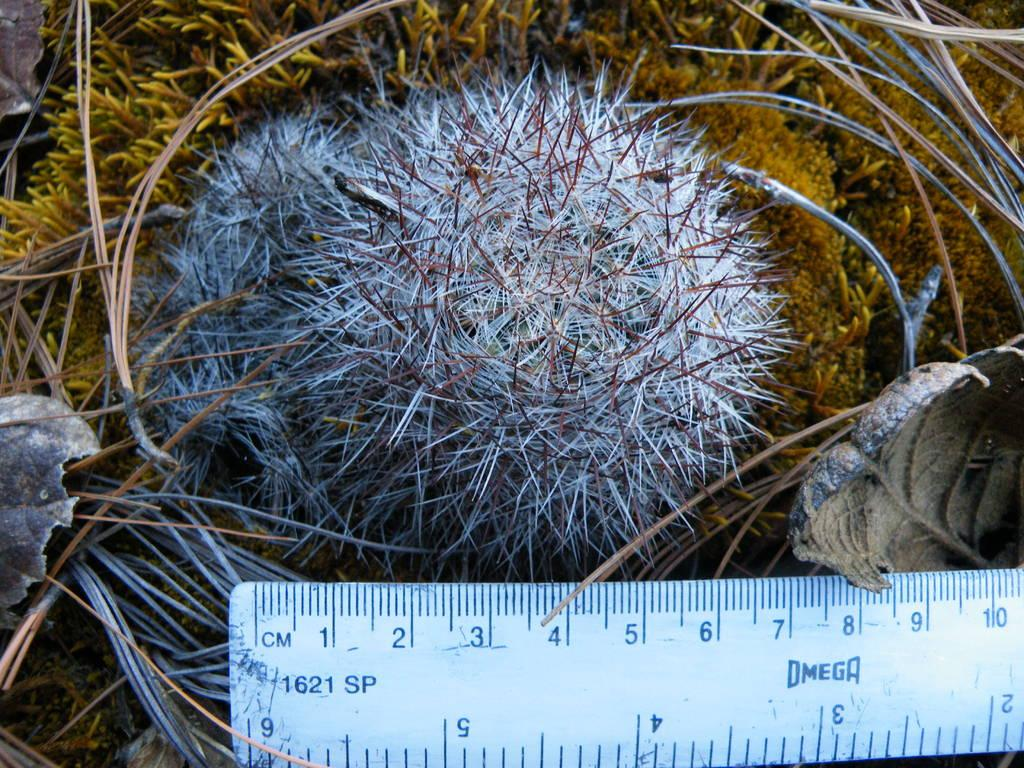<image>
Provide a brief description of the given image. A Omega ruler is being used to measure a round cactus. 